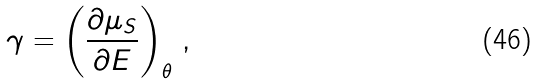<formula> <loc_0><loc_0><loc_500><loc_500>\gamma = \left ( \frac { \partial \mu _ { S } } { \partial E } \right ) _ { \theta } \, ,</formula> 